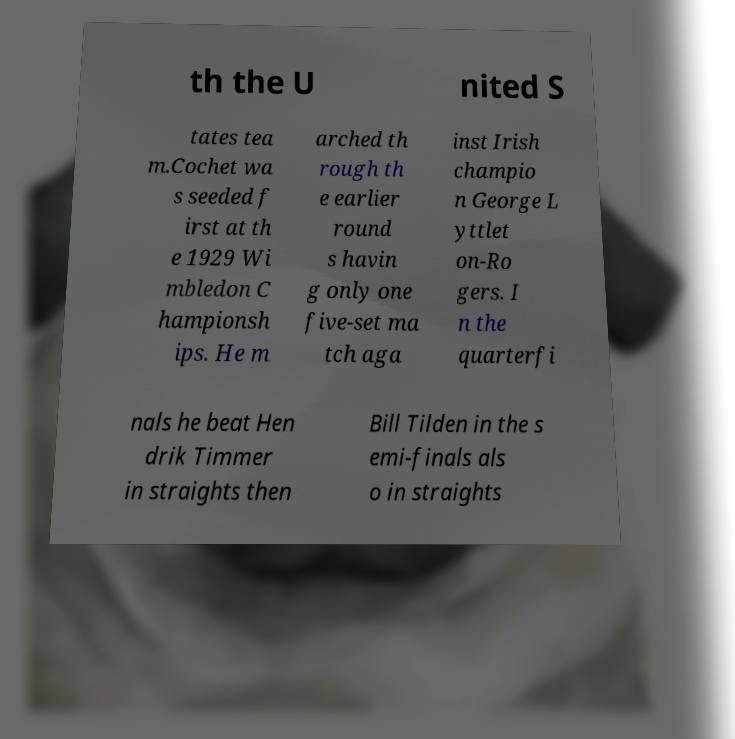For documentation purposes, I need the text within this image transcribed. Could you provide that? th the U nited S tates tea m.Cochet wa s seeded f irst at th e 1929 Wi mbledon C hampionsh ips. He m arched th rough th e earlier round s havin g only one five-set ma tch aga inst Irish champio n George L yttlet on-Ro gers. I n the quarterfi nals he beat Hen drik Timmer in straights then Bill Tilden in the s emi-finals als o in straights 